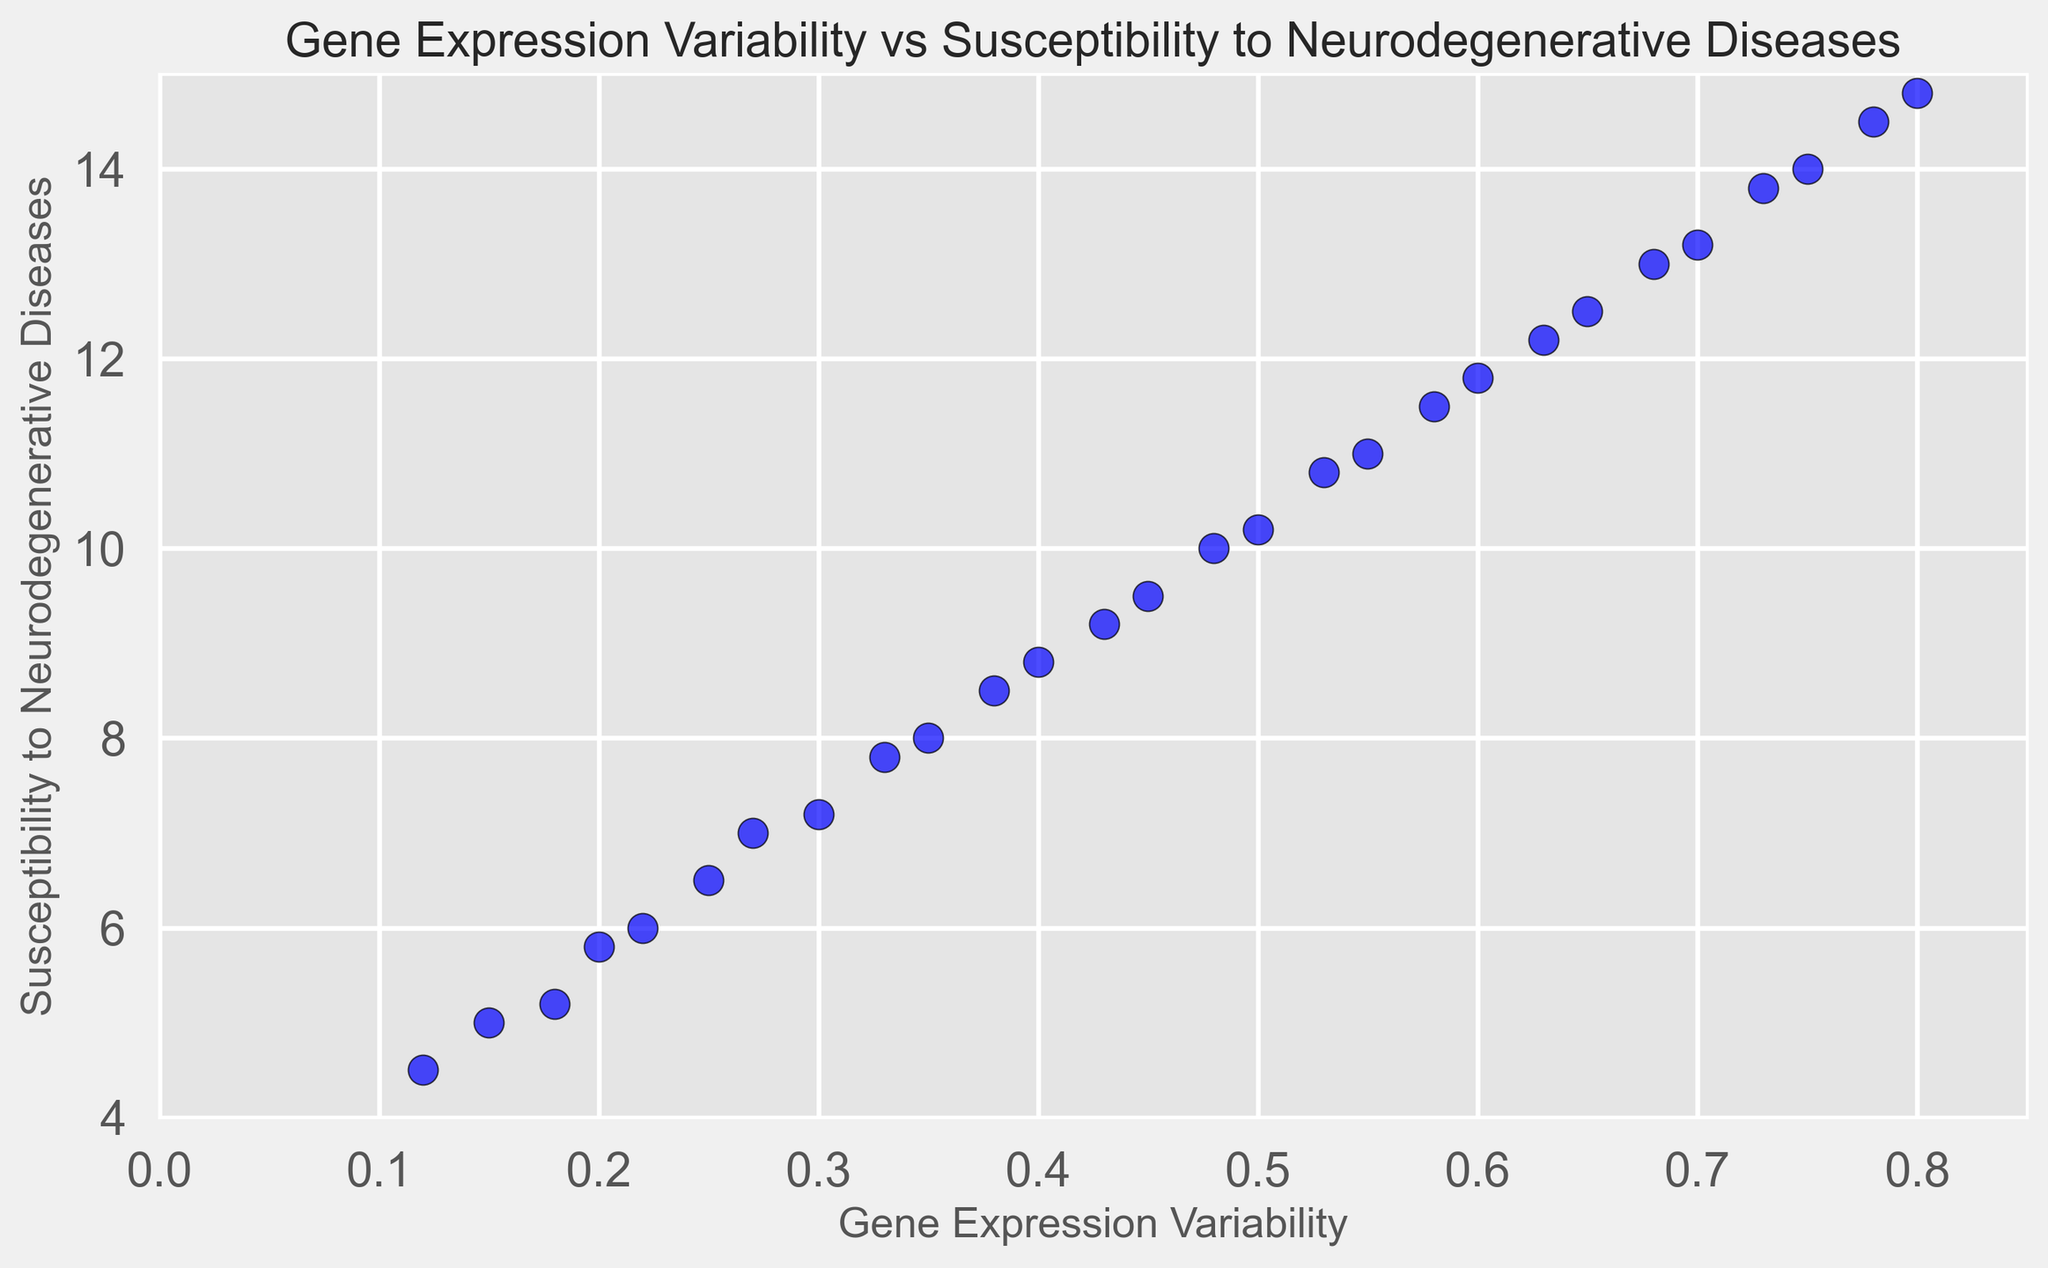What's the range of Gene Expression Variability values? The minimum value is 0.12 and the maximum value is 0.80. The range is calculated as maximum - minimum, which is 0.80 - 0.12.
Answer: 0.68 What does the plot suggest about the relationship between Gene Expression Variability and Susceptibility to Neurodegenerative Diseases? The plot shows a positive correlation, where an increase in Gene Expression Variability is associated with an increase in Susceptibility to Neurodegenerative Diseases.
Answer: Positive correlation What is the Susceptibility to Neurodegenerative Diseases when Gene Expression Variability is 0.43? From the scatter plot, locate the x-value of 0.43 on the Gene Expression Variability axis and find the corresponding y-value. This value is approximately 9.2.
Answer: 9.2 Is there a Gene Expression Variability value that corresponds to a Susceptibility to Neurodegenerative Diseases value of 14? Locate the y-value of 14 on the Susceptibility to Neurodegenerative Diseases axis and find the corresponding x-value. This value is approximately 0.75.
Answer: 0.75 Which data point has the highest Susceptibility to Neurodegenerative Diseases, and what is its Gene Expression Variability? Identify the y-value that is highest on the plot. The highest point is 14.8 on the y-axis, corresponding to a Gene Expression Variability of 0.80.
Answer: 0.80, 14.8 How many data points are there with a Susceptibility to Neurodegenerative Diseases value greater than 10? Count the number of data points above the y-axis value of 10. There are 9 such points: (0.53, 10.8), (0.55, 11.0), (0.58, 11.5), (0.60, 11.8), (0.63, 12.2), (0.65, 12.5), (0.68, 13.0), (0.70, 13.2), (0.73, 13.8), (0.75, 14.0), (0.78, 14.5), (0.80, 14.8).
Answer: 13 By how much does Susceptibility to Neurodegenerative Diseases increase when Gene Expression Variability increases from 0.22 to 0.25? Locate the data points for x-values of 0.22 and 0.25 and subtract the y-values. Susceptibility increases from 6.0 to 6.5, so the increase is 6.5 - 6.0.
Answer: 0.5 What is the average Susceptibility to Neurodegenerative Diseases for Gene Expression Variability values between 0.20 and 0.30? Identify the points: (0.20, 5.8), (0.22, 6.0), (0.25, 6.5), (0.27, 7.0), (0.30, 7.2). Calculate the average of the y-values: (5.8 + 6.0 + 6.5 + 7.0 + 7.2) / 5 = 32.5 / 5.
Answer: 6.5 